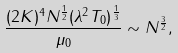Convert formula to latex. <formula><loc_0><loc_0><loc_500><loc_500>\frac { ( 2 K ) ^ { 4 } N ^ { \frac { 1 } { 2 } } ( \lambda ^ { 2 } T _ { 0 } ) ^ { \frac { 1 } { 3 } } } { \mu _ { 0 } } \sim N ^ { \frac { 3 } { 2 } } ,</formula> 